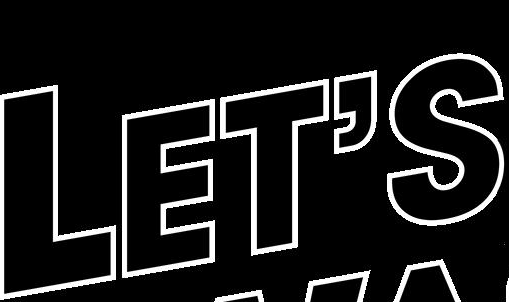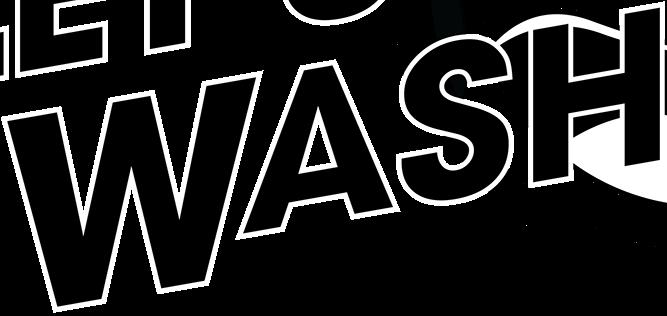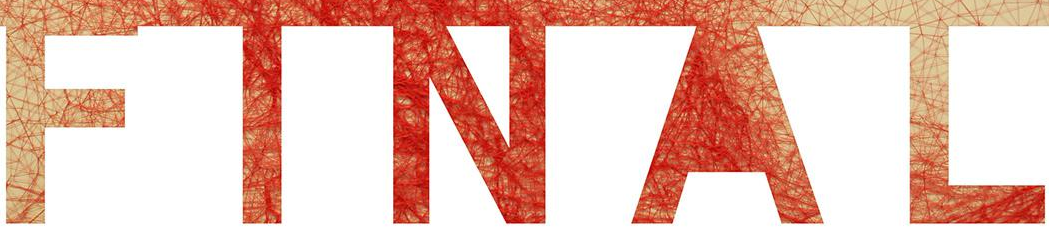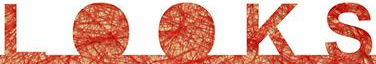What text is displayed in these images sequentially, separated by a semicolon? LET'S; WASH; FINAL; LOOKS 